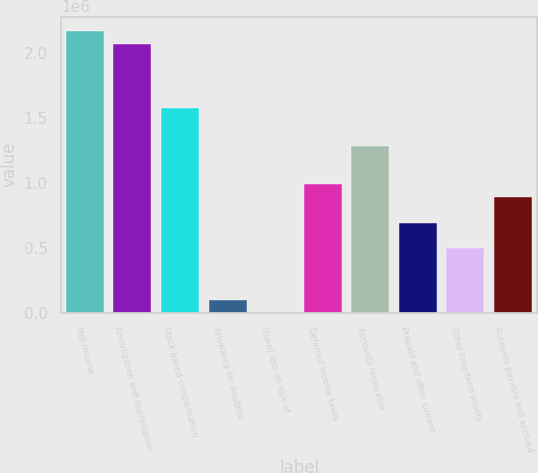Convert chart to OTSL. <chart><loc_0><loc_0><loc_500><loc_500><bar_chart><fcel>Net income<fcel>Amortization and depreciation<fcel>Stock-based compensation<fcel>Allowance for doubtful<fcel>(Gain) loss on sale of<fcel>Deferred income taxes<fcel>Accounts receivable<fcel>Prepaid and other current<fcel>Other long-term assets<fcel>Accounts payable and accrued<nl><fcel>2.16855e+06<fcel>2.06998e+06<fcel>1.57715e+06<fcel>98674.3<fcel>109<fcel>985762<fcel>1.28146e+06<fcel>690066<fcel>492936<fcel>887197<nl></chart> 